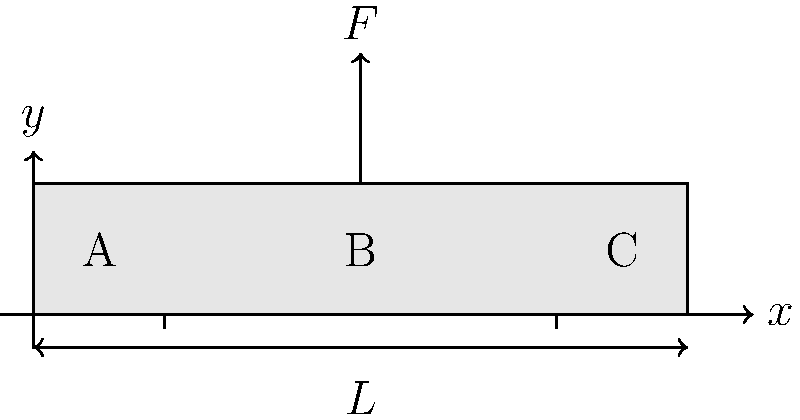In your yoga studio, a support beam spans a length $L$ and is subjected to a concentrated load $F$ at its midpoint. The beam's cross-section is rectangular with width $b$ and height $h$. If the maximum allowable bending stress is $\sigma_{allow}$, what is the minimum required height $h$ of the beam to ensure structural integrity? Express your answer in terms of $F$, $L$, $b$, and $\sigma_{allow}$. To determine the minimum required height of the beam, we'll follow these steps:

1) The maximum bending moment $M_{max}$ occurs at the midpoint of the beam (point B) and is given by:
   $$M_{max} = \frac{FL}{4}$$

2) The section modulus $S$ for a rectangular beam is:
   $$S = \frac{bh^2}{6}$$

3) The maximum bending stress $\sigma_{max}$ is related to the maximum moment and section modulus:
   $$\sigma_{max} = \frac{M_{max}}{S}$$

4) For structural integrity, we require $\sigma_{max} \leq \sigma_{allow}$:
   $$\frac{M_{max}}{S} \leq \sigma_{allow}$$

5) Substituting the expressions for $M_{max}$ and $S$:
   $$\frac{FL/4}{bh^2/6} \leq \sigma_{allow}$$

6) Simplifying and solving for $h$:
   $$\frac{3FL}{2bh^2} \leq \sigma_{allow}$$
   $$h^2 \geq \frac{3FL}{2b\sigma_{allow}}$$
   $$h \geq \sqrt{\frac{3FL}{2b\sigma_{allow}}}$$

Therefore, the minimum required height of the beam is:
$$h_{min} = \sqrt{\frac{3FL}{2b\sigma_{allow}}}$$
Answer: $h_{min} = \sqrt{\frac{3FL}{2b\sigma_{allow}}}$ 